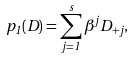<formula> <loc_0><loc_0><loc_500><loc_500>p _ { 1 } ( D ) = \sum _ { j = 1 } ^ { s } \beta ^ { j } D _ { + j } ,</formula> 